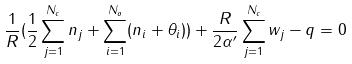<formula> <loc_0><loc_0><loc_500><loc_500>\frac { 1 } { R } ( \frac { 1 } { 2 } \sum _ { j = 1 } ^ { N _ { c } } n _ { j } + \sum _ { i = 1 } ^ { N _ { o } } ( n _ { i } + \theta _ { i } ) ) + \frac { R } { 2 \alpha ^ { \prime } } \sum _ { j = 1 } ^ { N _ { c } } w _ { j } - q = 0</formula> 